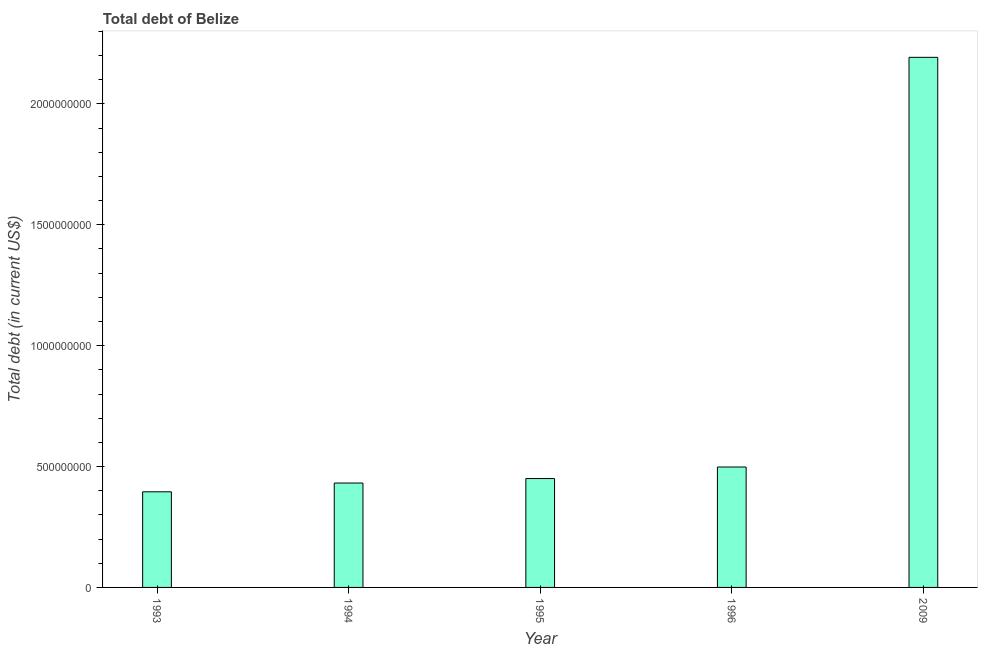What is the title of the graph?
Your answer should be very brief. Total debt of Belize. What is the label or title of the Y-axis?
Offer a very short reply. Total debt (in current US$). What is the total debt in 1995?
Your response must be concise. 4.50e+08. Across all years, what is the maximum total debt?
Give a very brief answer. 2.19e+09. Across all years, what is the minimum total debt?
Provide a short and direct response. 3.96e+08. In which year was the total debt maximum?
Make the answer very short. 2009. In which year was the total debt minimum?
Offer a very short reply. 1993. What is the sum of the total debt?
Keep it short and to the point. 3.97e+09. What is the difference between the total debt in 1993 and 1996?
Offer a very short reply. -1.03e+08. What is the average total debt per year?
Offer a very short reply. 7.94e+08. What is the median total debt?
Ensure brevity in your answer.  4.50e+08. In how many years, is the total debt greater than 300000000 US$?
Provide a succinct answer. 5. What is the ratio of the total debt in 1994 to that in 2009?
Provide a short and direct response. 0.2. Is the total debt in 1993 less than that in 1995?
Your answer should be compact. Yes. What is the difference between the highest and the second highest total debt?
Ensure brevity in your answer.  1.69e+09. What is the difference between the highest and the lowest total debt?
Give a very brief answer. 1.80e+09. How many years are there in the graph?
Your answer should be compact. 5. What is the difference between two consecutive major ticks on the Y-axis?
Offer a very short reply. 5.00e+08. What is the Total debt (in current US$) in 1993?
Give a very brief answer. 3.96e+08. What is the Total debt (in current US$) in 1994?
Your response must be concise. 4.32e+08. What is the Total debt (in current US$) of 1995?
Keep it short and to the point. 4.50e+08. What is the Total debt (in current US$) in 1996?
Your answer should be very brief. 4.98e+08. What is the Total debt (in current US$) in 2009?
Your answer should be very brief. 2.19e+09. What is the difference between the Total debt (in current US$) in 1993 and 1994?
Provide a succinct answer. -3.62e+07. What is the difference between the Total debt (in current US$) in 1993 and 1995?
Ensure brevity in your answer.  -5.48e+07. What is the difference between the Total debt (in current US$) in 1993 and 1996?
Your response must be concise. -1.03e+08. What is the difference between the Total debt (in current US$) in 1993 and 2009?
Keep it short and to the point. -1.80e+09. What is the difference between the Total debt (in current US$) in 1994 and 1995?
Offer a very short reply. -1.86e+07. What is the difference between the Total debt (in current US$) in 1994 and 1996?
Your answer should be very brief. -6.63e+07. What is the difference between the Total debt (in current US$) in 1994 and 2009?
Your answer should be very brief. -1.76e+09. What is the difference between the Total debt (in current US$) in 1995 and 1996?
Your answer should be very brief. -4.78e+07. What is the difference between the Total debt (in current US$) in 1995 and 2009?
Offer a terse response. -1.74e+09. What is the difference between the Total debt (in current US$) in 1996 and 2009?
Give a very brief answer. -1.69e+09. What is the ratio of the Total debt (in current US$) in 1993 to that in 1994?
Provide a short and direct response. 0.92. What is the ratio of the Total debt (in current US$) in 1993 to that in 1995?
Give a very brief answer. 0.88. What is the ratio of the Total debt (in current US$) in 1993 to that in 1996?
Give a very brief answer. 0.79. What is the ratio of the Total debt (in current US$) in 1993 to that in 2009?
Provide a succinct answer. 0.18. What is the ratio of the Total debt (in current US$) in 1994 to that in 1996?
Ensure brevity in your answer.  0.87. What is the ratio of the Total debt (in current US$) in 1994 to that in 2009?
Your answer should be compact. 0.2. What is the ratio of the Total debt (in current US$) in 1995 to that in 1996?
Give a very brief answer. 0.9. What is the ratio of the Total debt (in current US$) in 1995 to that in 2009?
Provide a short and direct response. 0.2. What is the ratio of the Total debt (in current US$) in 1996 to that in 2009?
Provide a short and direct response. 0.23. 